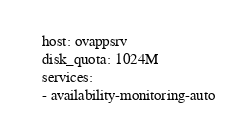Convert code to text. <code><loc_0><loc_0><loc_500><loc_500><_YAML_>  host: ovappsrv
  disk_quota: 1024M
  services:
  - availability-monitoring-auto
</code> 